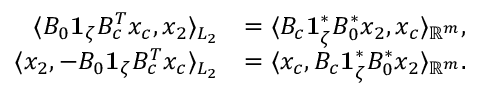<formula> <loc_0><loc_0><loc_500><loc_500>\begin{array} { r l } { \langle B _ { 0 } 1 _ { \zeta } B _ { c } ^ { T } x _ { c } , x _ { 2 } \rangle _ { L _ { 2 } } } & { = \langle B _ { c } 1 _ { \zeta } ^ { * } B _ { 0 } ^ { * } x _ { 2 } , x _ { c } \rangle _ { \mathbb { R } ^ { m } } , } \\ { \langle x _ { 2 } , - B _ { 0 } 1 _ { \zeta } B _ { c } ^ { T } x _ { c } \rangle _ { L _ { 2 } } } & { = \langle x _ { c } , B _ { c } 1 _ { \zeta } ^ { * } B _ { 0 } ^ { * } x _ { 2 } \rangle _ { \mathbb { R } ^ { m } } . } \end{array}</formula> 